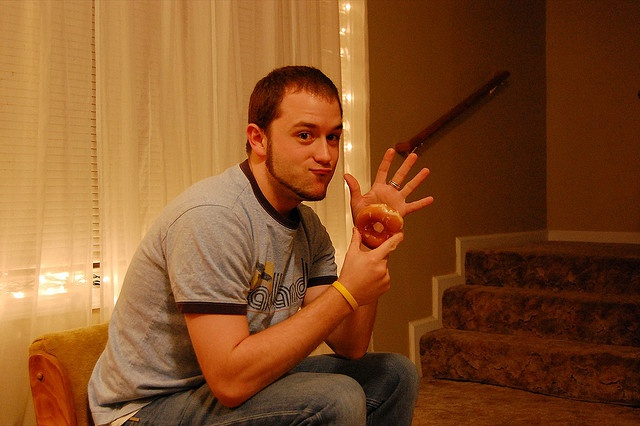Describe the objects in this image and their specific colors. I can see people in tan, maroon, black, and red tones, chair in tan, maroon, brown, and orange tones, and donut in tan, maroon, and red tones in this image. 